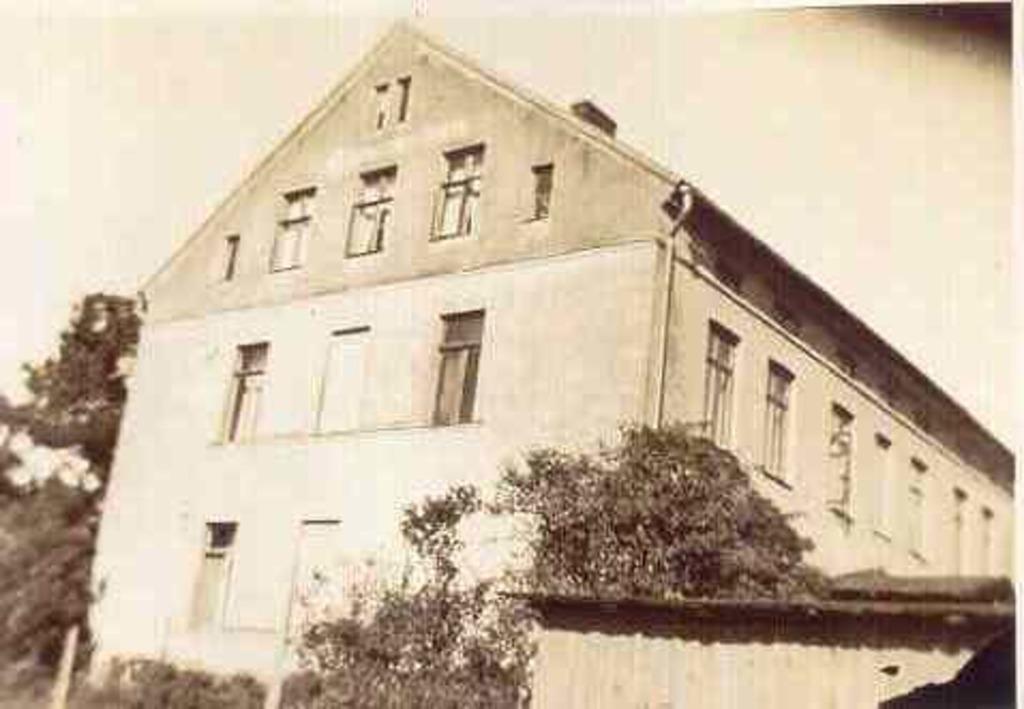Can you describe this image briefly? In this picture there is a building. On the right I can see many windows on the building. At the bottom I can see the fencing, plants, grass and shed. On the left I can see many trees. In the top left I can see the sky. 